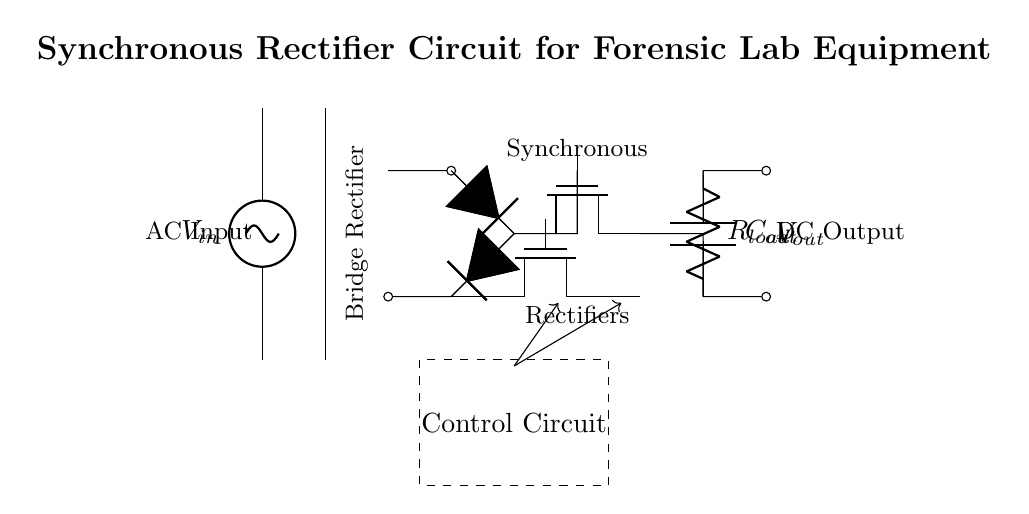what type of circuit is shown? The circuit is a synchronous rectifier circuit designed for power conversion. This can be deduced from the presence of synchronous rectifier MOSFETs and the title of the diagram.
Answer: synchronous rectifier circuit what components are used for rectification? The circuit uses two types of components for rectification: diodes labeled as D and MOSFETs labeled as M1 and M2. As indicated in the circuit, these components serve to convert AC into DC.
Answer: diodes and MOSFETs how many MOSFETs are present in the circuit? There are two MOSFETs present in the circuit, identified as M1 and M2. This is clear from the diagram, where each MOSFET is distinctly labeled in their respective positions.
Answer: two what is the purpose of the capacitor in the circuit? The capacitor, labeled as Cout, is used for filtering and stabilizing the output voltage by smoothing out pulsating DC. This is a common function of capacitors in power conversion circuits.
Answer: filtering and stabilizing output voltage how does the control circuit influence the MOSFET operation? The control circuit provides signals to the gate of the MOSFETs to switch them on and off at the correct times, ensuring efficient rectification. This is inferred from the dashed box labeled “Control Circuit” and the arrows indicating control signals.
Answer: switching MOSFETs on and off what is the load resistance in the circuit? The load resistance is labeled as Rload. The diagram indicates its position connected to the output of the rectifier circuitry, directly linked to the capacitor.
Answer: Rload how does this circuit enhance power conversion efficiency? This circuit enhances power conversion efficiency by using synchronous rectification, where MOSFETs replace diodes, reducing voltage drop and power loss during conduction. This can be determined from the MOSFETs marked as synchronous rectifiers in comparison to conventional diode circuits.
Answer: synchronous rectification 